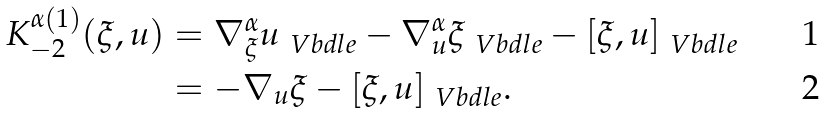<formula> <loc_0><loc_0><loc_500><loc_500>K _ { - 2 } ^ { \alpha ( 1 ) } ( \xi , u ) & = \nabla ^ { \alpha } _ { \xi } u _ { \ V b d l e } - \nabla ^ { \alpha } _ { u } \xi _ { \ V b d l e } - [ \xi , u ] _ { \ V b d l e } \\ & = - \nabla _ { u } \xi - [ \xi , u ] _ { \ V b d l e } .</formula> 